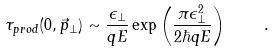Convert formula to latex. <formula><loc_0><loc_0><loc_500><loc_500>\tau _ { p r o d } ( 0 , \vec { p } _ { \perp } ) \sim { \frac { \epsilon _ { \perp } } { q E } } \exp \left ( { \frac { \pi \epsilon _ { \perp } ^ { 2 } } { 2 \hbar { q } E } } \right ) \quad .</formula> 